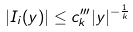Convert formula to latex. <formula><loc_0><loc_0><loc_500><loc_500>| I _ { i } ( y ) | \leq c ^ { \prime \prime \prime } _ { k } | y | ^ { - \frac { 1 } { k } }</formula> 